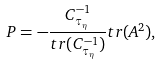Convert formula to latex. <formula><loc_0><loc_0><loc_500><loc_500>P = - \frac { C _ { \tau _ { \eta } } ^ { - 1 } } { t r ( C _ { \tau _ { \eta } } ^ { - 1 } ) } t r ( A ^ { 2 } ) ,</formula> 